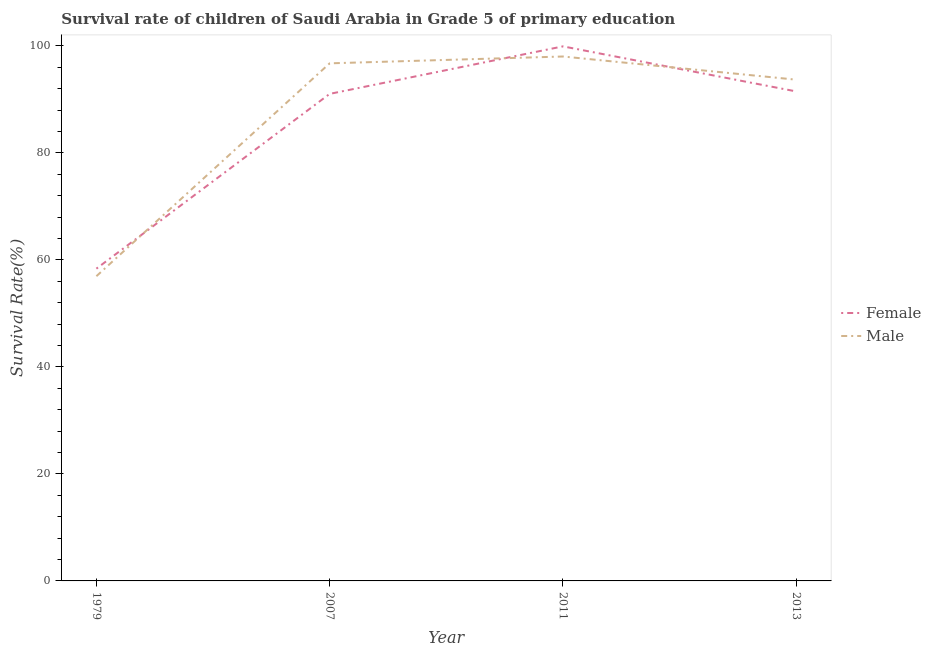How many different coloured lines are there?
Your answer should be very brief. 2. Does the line corresponding to survival rate of female students in primary education intersect with the line corresponding to survival rate of male students in primary education?
Ensure brevity in your answer.  Yes. Is the number of lines equal to the number of legend labels?
Keep it short and to the point. Yes. What is the survival rate of female students in primary education in 1979?
Offer a very short reply. 58.37. Across all years, what is the maximum survival rate of female students in primary education?
Your response must be concise. 99.92. Across all years, what is the minimum survival rate of female students in primary education?
Ensure brevity in your answer.  58.37. In which year was the survival rate of female students in primary education maximum?
Provide a short and direct response. 2011. In which year was the survival rate of male students in primary education minimum?
Provide a short and direct response. 1979. What is the total survival rate of male students in primary education in the graph?
Ensure brevity in your answer.  345.43. What is the difference between the survival rate of male students in primary education in 1979 and that in 2013?
Ensure brevity in your answer.  -36.73. What is the difference between the survival rate of female students in primary education in 2011 and the survival rate of male students in primary education in 2007?
Your answer should be compact. 3.17. What is the average survival rate of male students in primary education per year?
Offer a terse response. 86.36. In the year 1979, what is the difference between the survival rate of female students in primary education and survival rate of male students in primary education?
Your answer should be compact. 1.41. In how many years, is the survival rate of female students in primary education greater than 80 %?
Provide a succinct answer. 3. What is the ratio of the survival rate of male students in primary education in 2007 to that in 2013?
Offer a terse response. 1.03. Is the survival rate of male students in primary education in 1979 less than that in 2007?
Give a very brief answer. Yes. What is the difference between the highest and the second highest survival rate of male students in primary education?
Provide a short and direct response. 1.28. What is the difference between the highest and the lowest survival rate of male students in primary education?
Offer a terse response. 41.07. In how many years, is the survival rate of male students in primary education greater than the average survival rate of male students in primary education taken over all years?
Make the answer very short. 3. Does the survival rate of female students in primary education monotonically increase over the years?
Offer a very short reply. No. How many years are there in the graph?
Offer a terse response. 4. Does the graph contain grids?
Your answer should be compact. No. How many legend labels are there?
Provide a succinct answer. 2. What is the title of the graph?
Your answer should be very brief. Survival rate of children of Saudi Arabia in Grade 5 of primary education. Does "Netherlands" appear as one of the legend labels in the graph?
Give a very brief answer. No. What is the label or title of the X-axis?
Provide a succinct answer. Year. What is the label or title of the Y-axis?
Offer a very short reply. Survival Rate(%). What is the Survival Rate(%) in Female in 1979?
Offer a terse response. 58.37. What is the Survival Rate(%) of Male in 1979?
Ensure brevity in your answer.  56.96. What is the Survival Rate(%) of Female in 2007?
Make the answer very short. 91.04. What is the Survival Rate(%) of Male in 2007?
Provide a short and direct response. 96.75. What is the Survival Rate(%) in Female in 2011?
Offer a very short reply. 99.92. What is the Survival Rate(%) of Male in 2011?
Your response must be concise. 98.03. What is the Survival Rate(%) of Female in 2013?
Provide a short and direct response. 91.5. What is the Survival Rate(%) in Male in 2013?
Your answer should be very brief. 93.69. Across all years, what is the maximum Survival Rate(%) in Female?
Give a very brief answer. 99.92. Across all years, what is the maximum Survival Rate(%) in Male?
Ensure brevity in your answer.  98.03. Across all years, what is the minimum Survival Rate(%) of Female?
Ensure brevity in your answer.  58.37. Across all years, what is the minimum Survival Rate(%) of Male?
Your response must be concise. 56.96. What is the total Survival Rate(%) of Female in the graph?
Offer a terse response. 340.83. What is the total Survival Rate(%) of Male in the graph?
Offer a terse response. 345.43. What is the difference between the Survival Rate(%) in Female in 1979 and that in 2007?
Offer a terse response. -32.67. What is the difference between the Survival Rate(%) in Male in 1979 and that in 2007?
Provide a short and direct response. -39.79. What is the difference between the Survival Rate(%) in Female in 1979 and that in 2011?
Your answer should be compact. -41.55. What is the difference between the Survival Rate(%) of Male in 1979 and that in 2011?
Ensure brevity in your answer.  -41.07. What is the difference between the Survival Rate(%) in Female in 1979 and that in 2013?
Provide a succinct answer. -33.13. What is the difference between the Survival Rate(%) in Male in 1979 and that in 2013?
Provide a short and direct response. -36.73. What is the difference between the Survival Rate(%) of Female in 2007 and that in 2011?
Keep it short and to the point. -8.88. What is the difference between the Survival Rate(%) of Male in 2007 and that in 2011?
Keep it short and to the point. -1.28. What is the difference between the Survival Rate(%) in Female in 2007 and that in 2013?
Your answer should be compact. -0.46. What is the difference between the Survival Rate(%) of Male in 2007 and that in 2013?
Keep it short and to the point. 3.06. What is the difference between the Survival Rate(%) of Female in 2011 and that in 2013?
Keep it short and to the point. 8.42. What is the difference between the Survival Rate(%) in Male in 2011 and that in 2013?
Provide a short and direct response. 4.33. What is the difference between the Survival Rate(%) of Female in 1979 and the Survival Rate(%) of Male in 2007?
Keep it short and to the point. -38.38. What is the difference between the Survival Rate(%) in Female in 1979 and the Survival Rate(%) in Male in 2011?
Provide a short and direct response. -39.66. What is the difference between the Survival Rate(%) of Female in 1979 and the Survival Rate(%) of Male in 2013?
Ensure brevity in your answer.  -35.32. What is the difference between the Survival Rate(%) in Female in 2007 and the Survival Rate(%) in Male in 2011?
Keep it short and to the point. -6.99. What is the difference between the Survival Rate(%) of Female in 2007 and the Survival Rate(%) of Male in 2013?
Give a very brief answer. -2.65. What is the difference between the Survival Rate(%) in Female in 2011 and the Survival Rate(%) in Male in 2013?
Your answer should be very brief. 6.23. What is the average Survival Rate(%) in Female per year?
Ensure brevity in your answer.  85.21. What is the average Survival Rate(%) in Male per year?
Offer a very short reply. 86.36. In the year 1979, what is the difference between the Survival Rate(%) of Female and Survival Rate(%) of Male?
Make the answer very short. 1.41. In the year 2007, what is the difference between the Survival Rate(%) in Female and Survival Rate(%) in Male?
Your answer should be very brief. -5.71. In the year 2011, what is the difference between the Survival Rate(%) of Female and Survival Rate(%) of Male?
Your answer should be very brief. 1.89. In the year 2013, what is the difference between the Survival Rate(%) of Female and Survival Rate(%) of Male?
Give a very brief answer. -2.19. What is the ratio of the Survival Rate(%) of Female in 1979 to that in 2007?
Keep it short and to the point. 0.64. What is the ratio of the Survival Rate(%) of Male in 1979 to that in 2007?
Provide a succinct answer. 0.59. What is the ratio of the Survival Rate(%) of Female in 1979 to that in 2011?
Your response must be concise. 0.58. What is the ratio of the Survival Rate(%) of Male in 1979 to that in 2011?
Keep it short and to the point. 0.58. What is the ratio of the Survival Rate(%) of Female in 1979 to that in 2013?
Your response must be concise. 0.64. What is the ratio of the Survival Rate(%) in Male in 1979 to that in 2013?
Provide a short and direct response. 0.61. What is the ratio of the Survival Rate(%) of Female in 2007 to that in 2011?
Give a very brief answer. 0.91. What is the ratio of the Survival Rate(%) of Male in 2007 to that in 2011?
Give a very brief answer. 0.99. What is the ratio of the Survival Rate(%) in Male in 2007 to that in 2013?
Make the answer very short. 1.03. What is the ratio of the Survival Rate(%) of Female in 2011 to that in 2013?
Offer a very short reply. 1.09. What is the ratio of the Survival Rate(%) in Male in 2011 to that in 2013?
Provide a short and direct response. 1.05. What is the difference between the highest and the second highest Survival Rate(%) in Female?
Give a very brief answer. 8.42. What is the difference between the highest and the second highest Survival Rate(%) of Male?
Make the answer very short. 1.28. What is the difference between the highest and the lowest Survival Rate(%) in Female?
Make the answer very short. 41.55. What is the difference between the highest and the lowest Survival Rate(%) of Male?
Your answer should be compact. 41.07. 